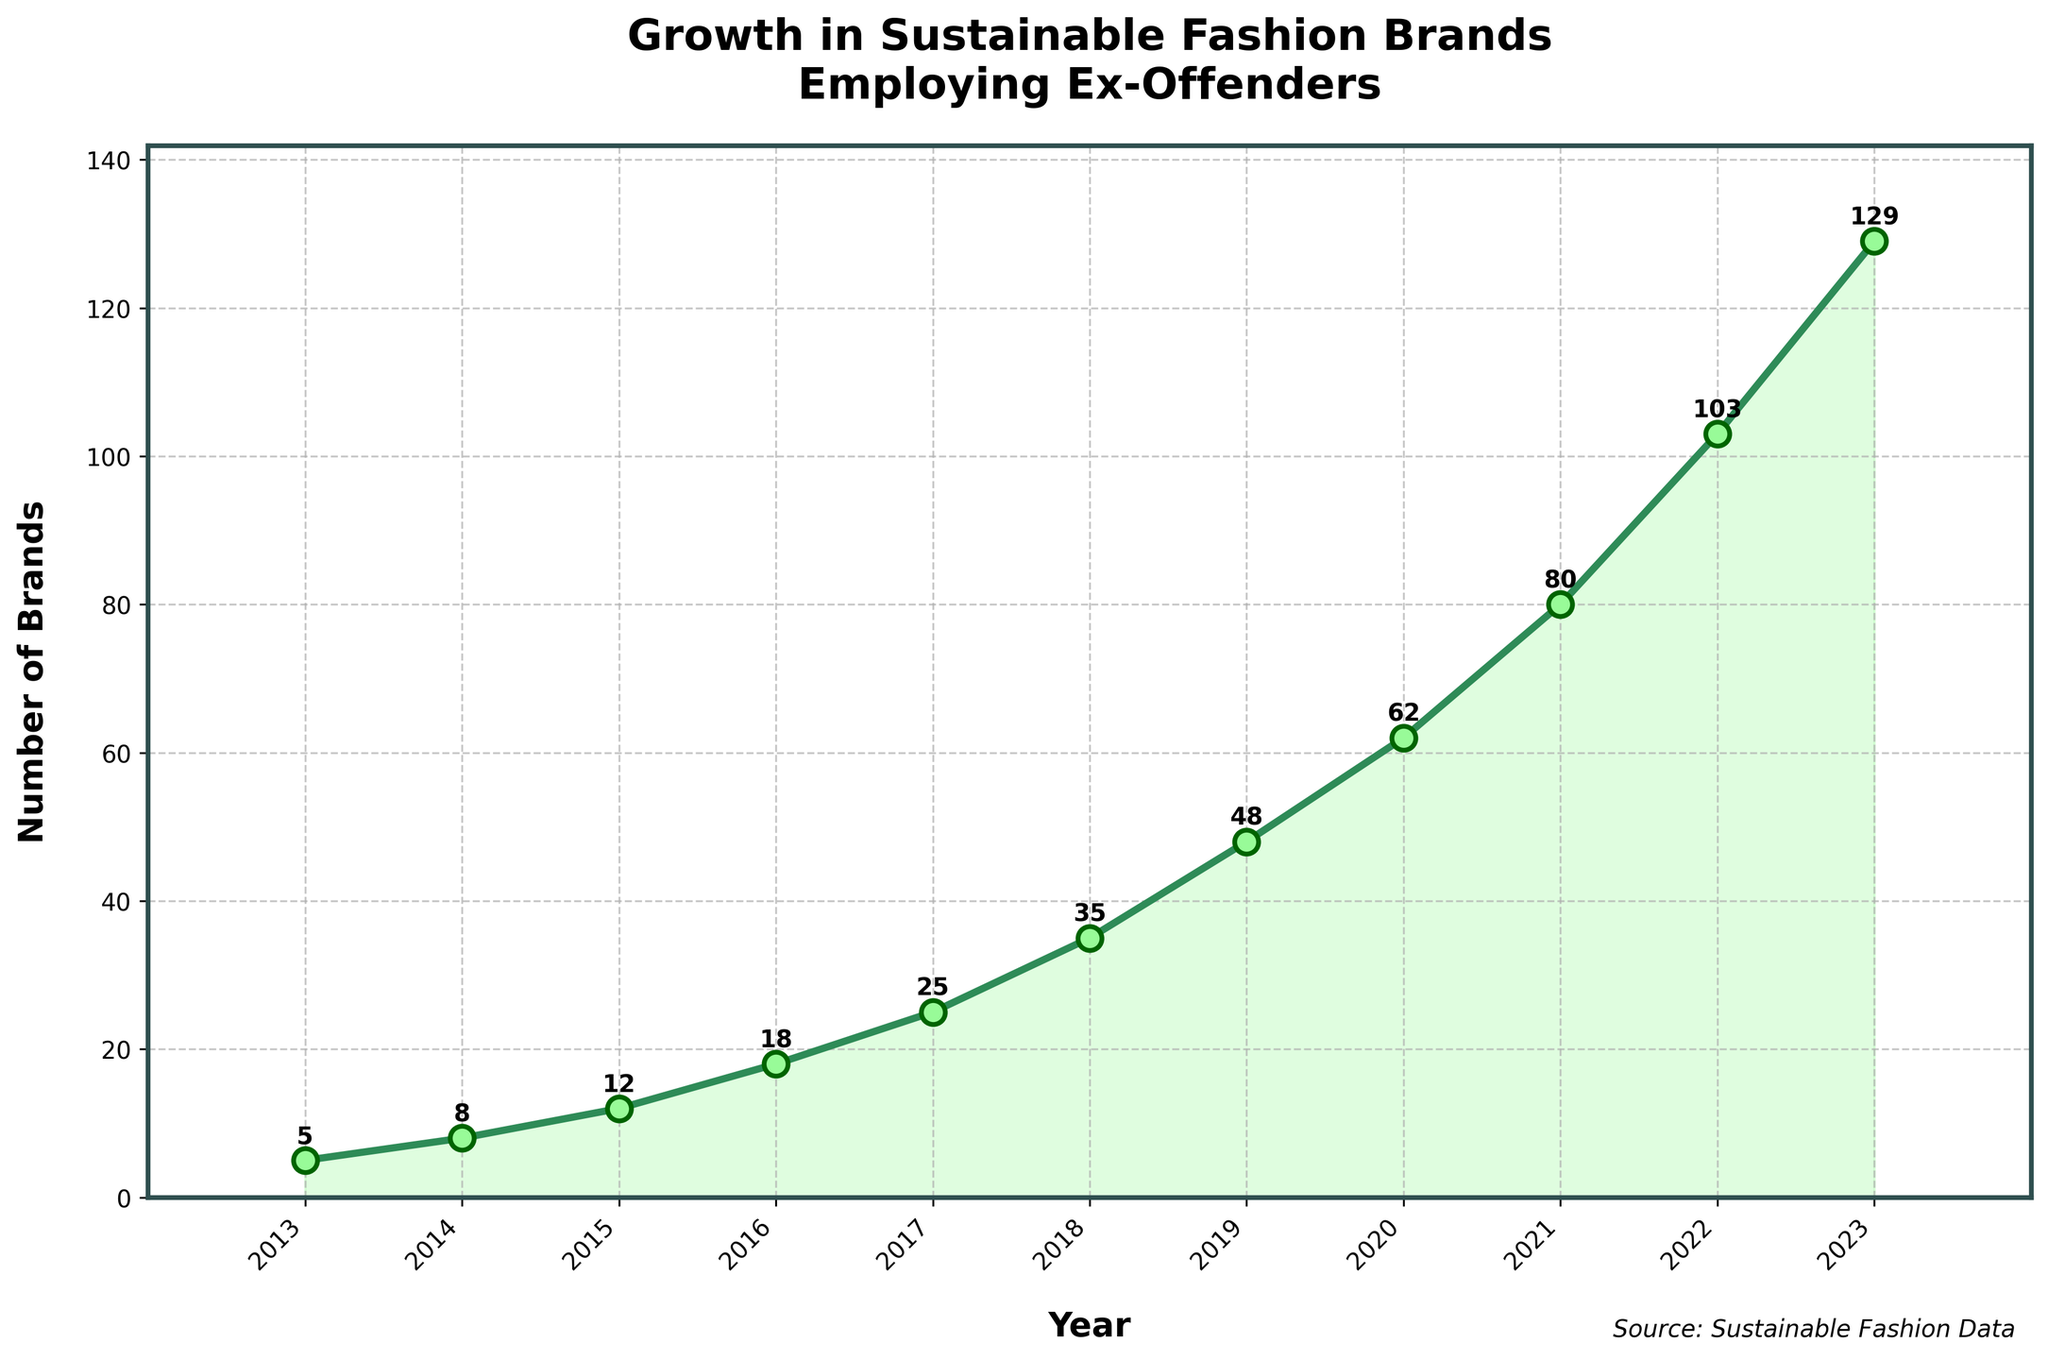What is the difference in the number of sustainable fashion brands employing ex-offenders between 2013 and 2023? To calculate the difference, subtract the number of brands in 2013 (5) from the number of brands in 2023 (129). The difference is 129 - 5 = 124.
Answer: 124 How many sustainable fashion brands employed ex-offenders in 2016? Refer to the data point for the year 2016 on the figure, which shows that there were 18 brands.
Answer: 18 Which year saw the highest increase in the number of sustainable fashion brands employing ex-offenders? To determine the highest increase, calculate the differences between consecutive years: 
2014-2013: 3, 
2015-2014: 4, 
2016-2015: 6, 
2017-2016: 7, 
2018-2017: 10, 
2019-2018: 13, 
2020-2019: 14, 
2021-2020: 18, 
2022-2021: 23, 
2023-2022: 26; 
The highest increase is from 2022 to 2023 by 26.
Answer: 2023 What is the average annual growth in the number of sustainable fashion brands employing ex-offenders from 2013 to 2023? Sum the number of brands each year: 5 + 8 + 12 + 18 + 25 + 35 + 48 + 62 + 80 + 103 + 129 = 525. There are 11 years in total, so the average is 525 / 11 = 47.73.
Answer: 47.73 What is the total number of sustainable fashion brands employing ex-offenders in 2019 and 2020 combined? Add the number of brands in 2019 (48) and 2020 (62): 48 + 62 = 110.
Answer: 110 How did the number of sustainable fashion brands employing ex-offenders change from 2014 to 2015? Did it increase, decrease, or stay the same? Compare the number of brands in 2014 (8) and 2015 (12). Since 12 > 8, the number increased.
Answer: Increased What is the percentage increase in the number of sustainable fashion brands employing ex-offenders from 2020 to 2021? Use the formula for percentage increase: ((New Number - Old Number) / Old Number) * 100. Here, ((80 - 62) / 62) * 100 = (18 / 62) * 100 ≈ 29.03%.
Answer: 29.03% Which year had exactly double the number of sustainable fashion brands employing ex-offenders compared to 2014? In 2014, there were 8 brands. We look for a year with 8 * 2 = 16 brands. From the data, 2016 had 18 brands, which is the closest but slightly above double.
Answer: None What is the median number of sustainable fashion brands employing ex-offenders during the period from 2013 to 2023? First, order the numbers: 5, 8, 12, 18, 25, 35, 48, 62, 80, 103, 129. There are 11 values, so the median is the 6th value, which is 35.
Answer: 35 